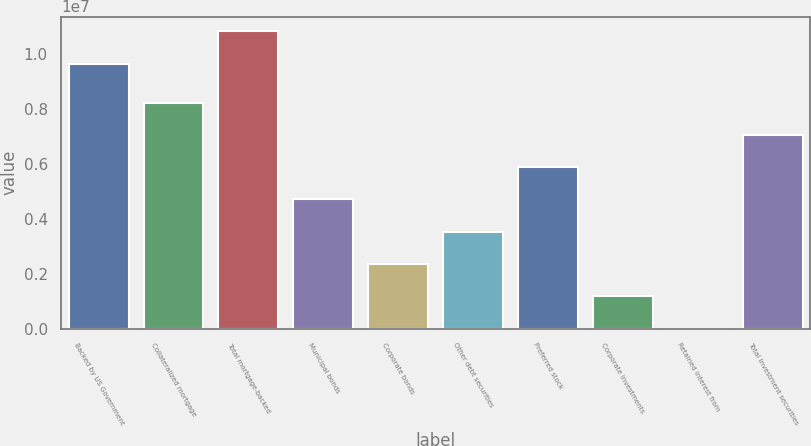Convert chart to OTSL. <chart><loc_0><loc_0><loc_500><loc_500><bar_chart><fcel>Backed by US Government<fcel>Collateralized mortgage<fcel>Total mortgage-backed<fcel>Municipal bonds<fcel>Corporate bonds<fcel>Other debt securities<fcel>Preferred stock<fcel>Corporate investments<fcel>Retained interest from<fcel>Total investment securities<nl><fcel>9.63868e+06<fcel>8.22732e+06<fcel>1.08139e+07<fcel>4.70174e+06<fcel>2.35136e+06<fcel>3.52655e+06<fcel>5.87693e+06<fcel>1.17617e+06<fcel>980<fcel>7.05212e+06<nl></chart> 